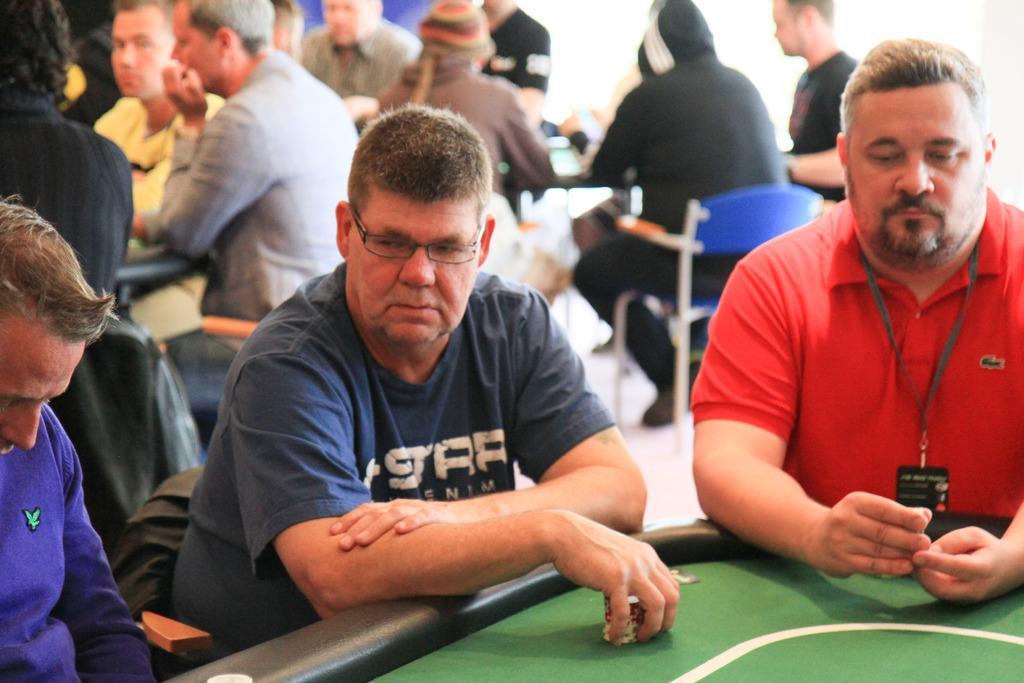Describe this image in one or two sentences. In this image there are many people sitting on a chairs. At the top of the image there is a table to play cards. In the right side of the image a man is sitting on a chair. This image is taken in a room. 